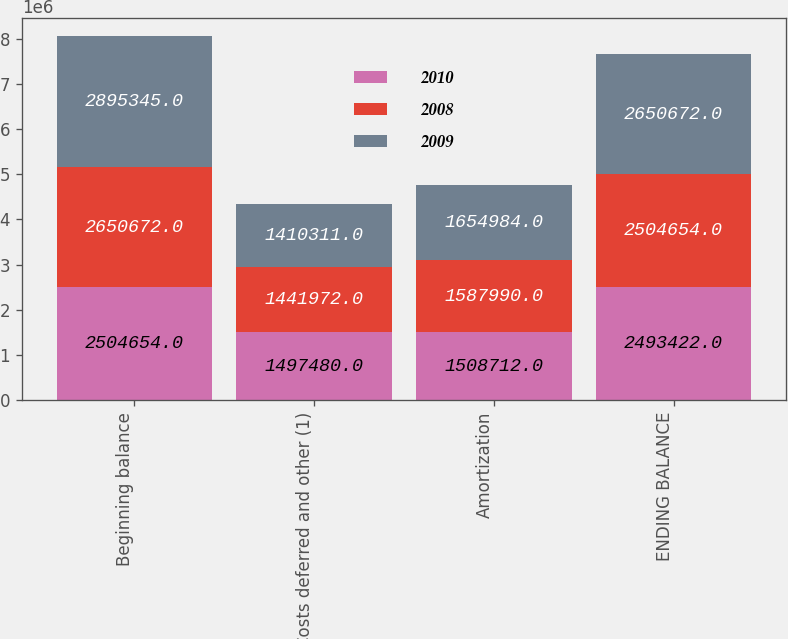<chart> <loc_0><loc_0><loc_500><loc_500><stacked_bar_chart><ecel><fcel>Beginning balance<fcel>Costs deferred and other (1)<fcel>Amortization<fcel>ENDING BALANCE<nl><fcel>2010<fcel>2.50465e+06<fcel>1.49748e+06<fcel>1.50871e+06<fcel>2.49342e+06<nl><fcel>2008<fcel>2.65067e+06<fcel>1.44197e+06<fcel>1.58799e+06<fcel>2.50465e+06<nl><fcel>2009<fcel>2.89534e+06<fcel>1.41031e+06<fcel>1.65498e+06<fcel>2.65067e+06<nl></chart> 